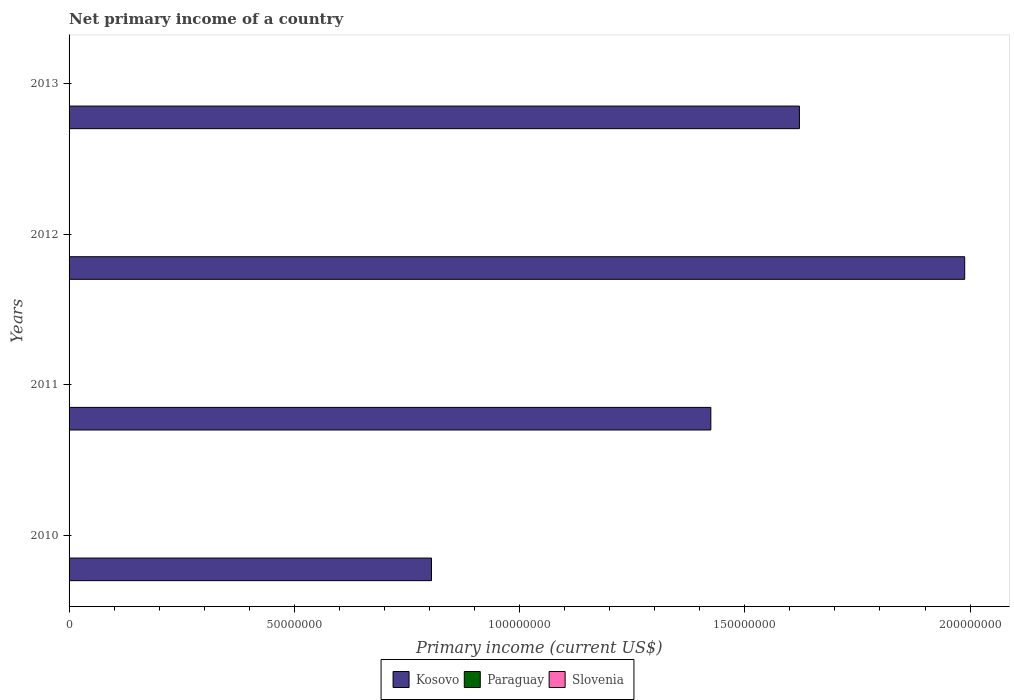How many different coloured bars are there?
Offer a terse response. 1. Are the number of bars on each tick of the Y-axis equal?
Make the answer very short. Yes. What is the label of the 1st group of bars from the top?
Your response must be concise. 2013. In how many cases, is the number of bars for a given year not equal to the number of legend labels?
Offer a terse response. 4. What is the primary income in Kosovo in 2011?
Keep it short and to the point. 1.42e+08. Across all years, what is the maximum primary income in Kosovo?
Give a very brief answer. 1.99e+08. In which year was the primary income in Kosovo maximum?
Make the answer very short. 2012. What is the difference between the primary income in Kosovo in 2011 and that in 2013?
Your answer should be very brief. -1.97e+07. What is the difference between the primary income in Paraguay in 2010 and the primary income in Slovenia in 2013?
Make the answer very short. 0. What is the ratio of the primary income in Kosovo in 2010 to that in 2012?
Offer a terse response. 0.4. What is the difference between the highest and the second highest primary income in Kosovo?
Offer a very short reply. 3.67e+07. What is the difference between the highest and the lowest primary income in Kosovo?
Offer a terse response. 1.18e+08. In how many years, is the primary income in Paraguay greater than the average primary income in Paraguay taken over all years?
Your response must be concise. 0. Is the sum of the primary income in Kosovo in 2010 and 2011 greater than the maximum primary income in Paraguay across all years?
Provide a succinct answer. Yes. Is it the case that in every year, the sum of the primary income in Kosovo and primary income in Paraguay is greater than the primary income in Slovenia?
Provide a short and direct response. Yes. How many bars are there?
Offer a terse response. 4. Are all the bars in the graph horizontal?
Your response must be concise. Yes. How many years are there in the graph?
Keep it short and to the point. 4. What is the difference between two consecutive major ticks on the X-axis?
Keep it short and to the point. 5.00e+07. How many legend labels are there?
Keep it short and to the point. 3. How are the legend labels stacked?
Keep it short and to the point. Horizontal. What is the title of the graph?
Keep it short and to the point. Net primary income of a country. What is the label or title of the X-axis?
Your response must be concise. Primary income (current US$). What is the Primary income (current US$) of Kosovo in 2010?
Offer a terse response. 8.05e+07. What is the Primary income (current US$) in Paraguay in 2010?
Your response must be concise. 0. What is the Primary income (current US$) of Kosovo in 2011?
Give a very brief answer. 1.42e+08. What is the Primary income (current US$) of Paraguay in 2011?
Offer a very short reply. 0. What is the Primary income (current US$) in Kosovo in 2012?
Provide a short and direct response. 1.99e+08. What is the Primary income (current US$) in Kosovo in 2013?
Make the answer very short. 1.62e+08. Across all years, what is the maximum Primary income (current US$) in Kosovo?
Your answer should be compact. 1.99e+08. Across all years, what is the minimum Primary income (current US$) of Kosovo?
Provide a succinct answer. 8.05e+07. What is the total Primary income (current US$) of Kosovo in the graph?
Provide a succinct answer. 5.84e+08. What is the difference between the Primary income (current US$) in Kosovo in 2010 and that in 2011?
Offer a very short reply. -6.20e+07. What is the difference between the Primary income (current US$) of Kosovo in 2010 and that in 2012?
Your answer should be very brief. -1.18e+08. What is the difference between the Primary income (current US$) of Kosovo in 2010 and that in 2013?
Offer a very short reply. -8.17e+07. What is the difference between the Primary income (current US$) in Kosovo in 2011 and that in 2012?
Your response must be concise. -5.64e+07. What is the difference between the Primary income (current US$) in Kosovo in 2011 and that in 2013?
Give a very brief answer. -1.97e+07. What is the difference between the Primary income (current US$) in Kosovo in 2012 and that in 2013?
Your answer should be very brief. 3.67e+07. What is the average Primary income (current US$) of Kosovo per year?
Provide a succinct answer. 1.46e+08. What is the average Primary income (current US$) in Paraguay per year?
Give a very brief answer. 0. What is the average Primary income (current US$) in Slovenia per year?
Make the answer very short. 0. What is the ratio of the Primary income (current US$) of Kosovo in 2010 to that in 2011?
Your response must be concise. 0.56. What is the ratio of the Primary income (current US$) in Kosovo in 2010 to that in 2012?
Ensure brevity in your answer.  0.4. What is the ratio of the Primary income (current US$) of Kosovo in 2010 to that in 2013?
Offer a very short reply. 0.5. What is the ratio of the Primary income (current US$) of Kosovo in 2011 to that in 2012?
Your response must be concise. 0.72. What is the ratio of the Primary income (current US$) in Kosovo in 2011 to that in 2013?
Your answer should be compact. 0.88. What is the ratio of the Primary income (current US$) in Kosovo in 2012 to that in 2013?
Make the answer very short. 1.23. What is the difference between the highest and the second highest Primary income (current US$) of Kosovo?
Keep it short and to the point. 3.67e+07. What is the difference between the highest and the lowest Primary income (current US$) in Kosovo?
Ensure brevity in your answer.  1.18e+08. 